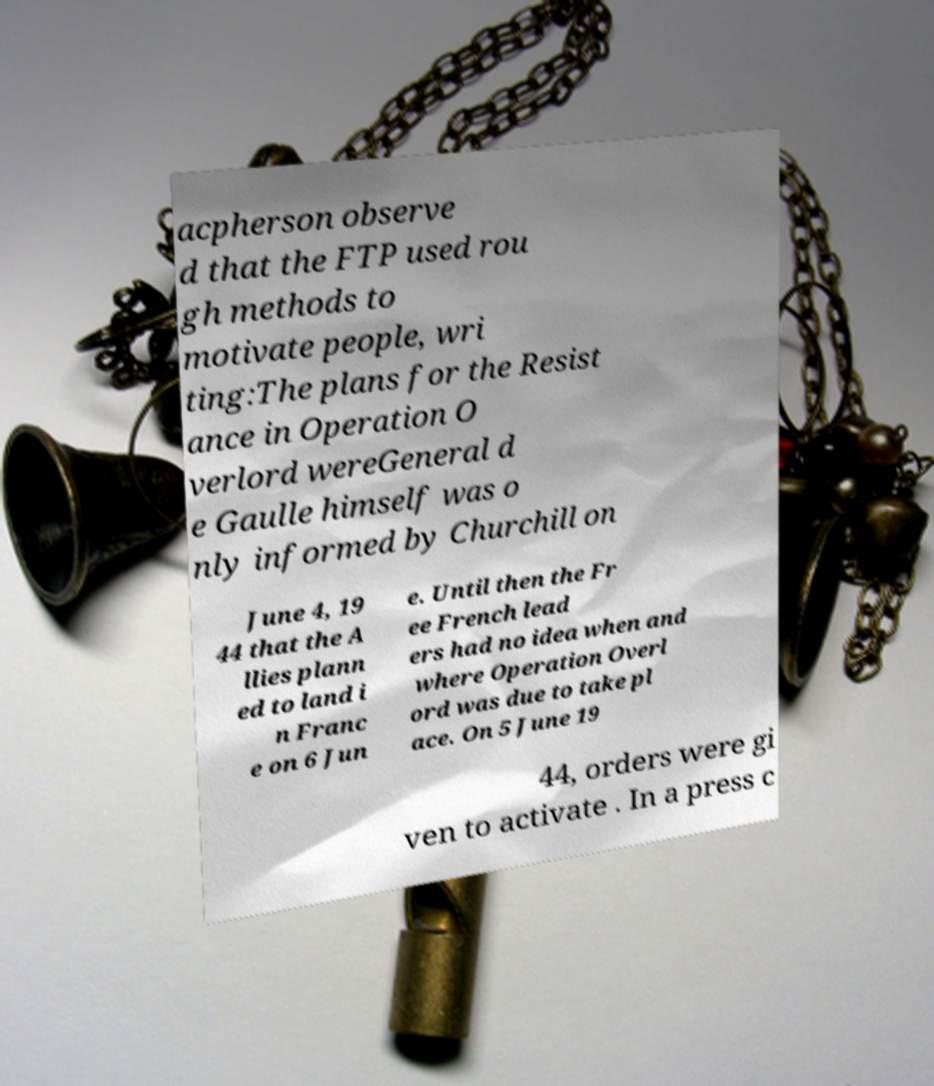For documentation purposes, I need the text within this image transcribed. Could you provide that? acpherson observe d that the FTP used rou gh methods to motivate people, wri ting:The plans for the Resist ance in Operation O verlord wereGeneral d e Gaulle himself was o nly informed by Churchill on June 4, 19 44 that the A llies plann ed to land i n Franc e on 6 Jun e. Until then the Fr ee French lead ers had no idea when and where Operation Overl ord was due to take pl ace. On 5 June 19 44, orders were gi ven to activate . In a press c 